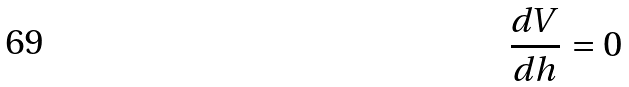Convert formula to latex. <formula><loc_0><loc_0><loc_500><loc_500>\frac { d V } { d h } = 0</formula> 